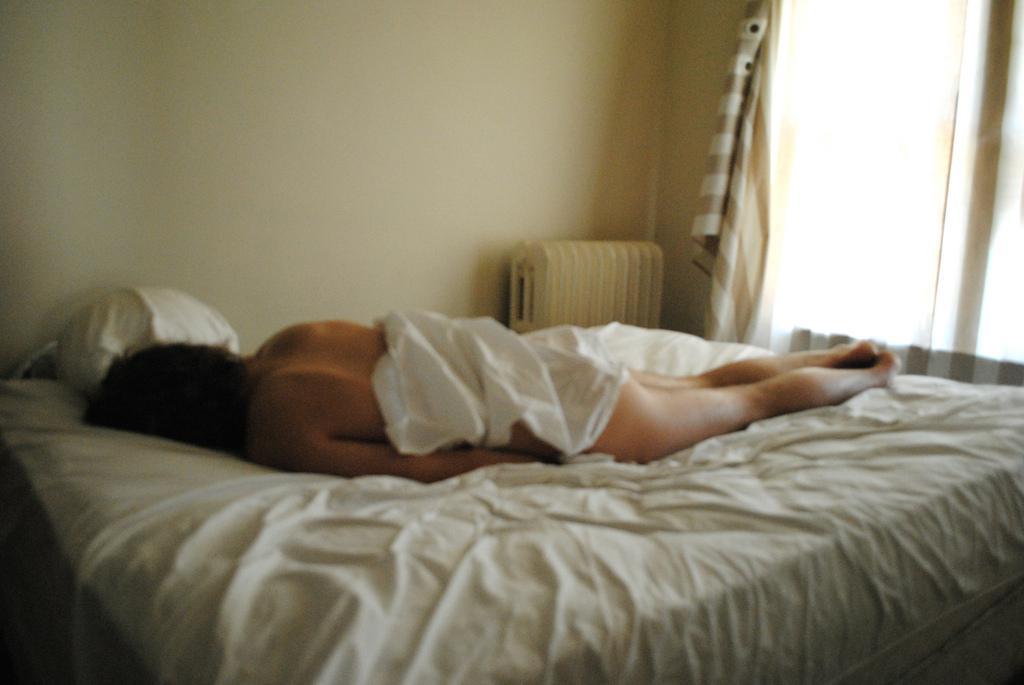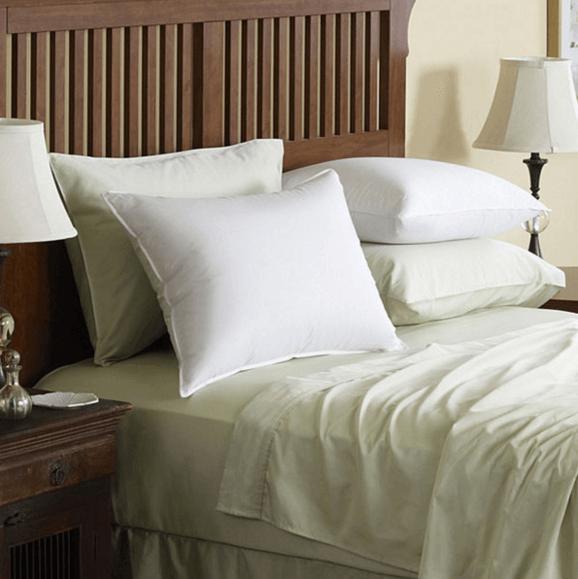The first image is the image on the left, the second image is the image on the right. Assess this claim about the two images: "An image shows a person with bare legs on a bed next to a window with a fabric drape.". Correct or not? Answer yes or no. Yes. The first image is the image on the left, the second image is the image on the right. Evaluate the accuracy of this statement regarding the images: "A person is laying in the bed in the image on the left.". Is it true? Answer yes or no. Yes. 